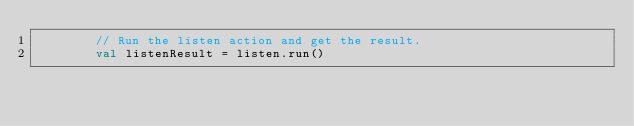Convert code to text. <code><loc_0><loc_0><loc_500><loc_500><_Kotlin_>        // Run the listen action and get the result.
        val listenResult = listen.run()
</code> 